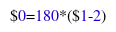<code> <loc_0><loc_0><loc_500><loc_500><_Awk_>$0=180*($1-2)</code> 